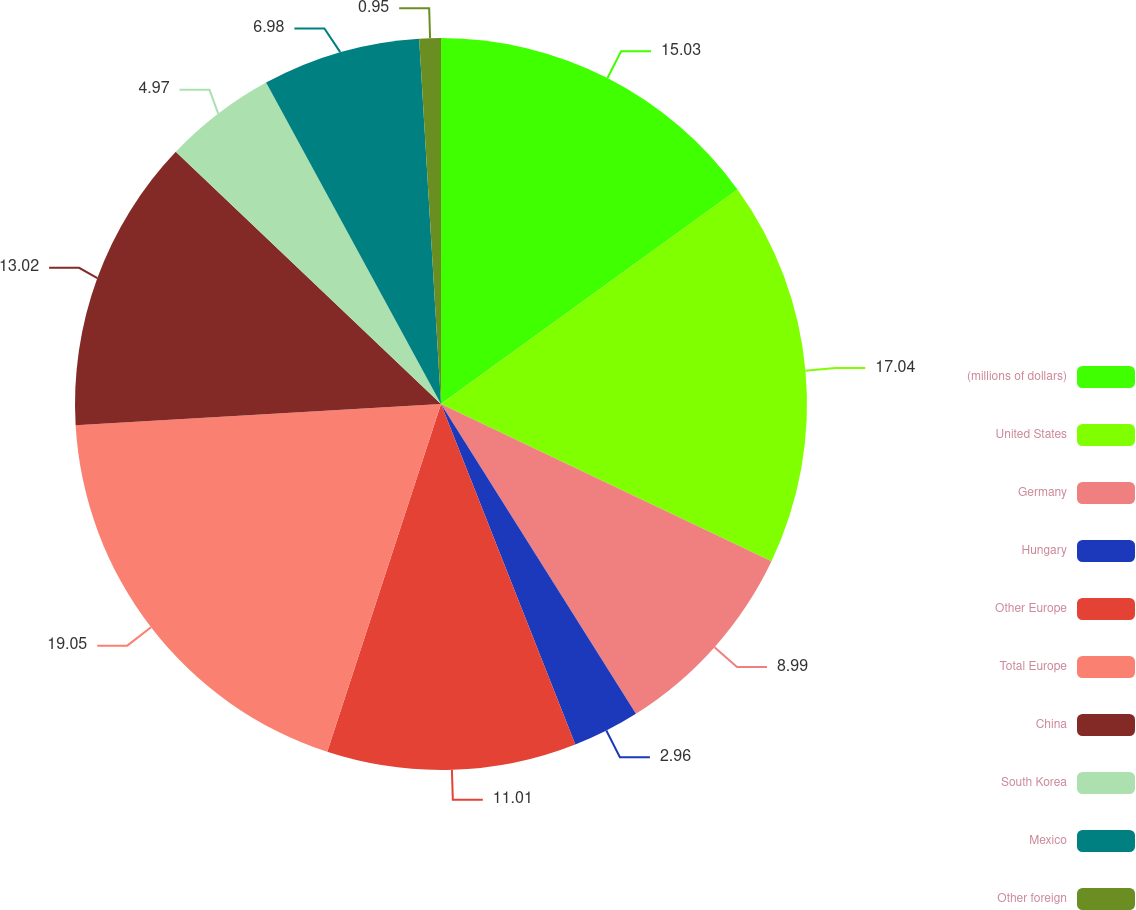Convert chart. <chart><loc_0><loc_0><loc_500><loc_500><pie_chart><fcel>(millions of dollars)<fcel>United States<fcel>Germany<fcel>Hungary<fcel>Other Europe<fcel>Total Europe<fcel>China<fcel>South Korea<fcel>Mexico<fcel>Other foreign<nl><fcel>15.03%<fcel>17.04%<fcel>8.99%<fcel>2.96%<fcel>11.01%<fcel>19.05%<fcel>13.02%<fcel>4.97%<fcel>6.98%<fcel>0.95%<nl></chart> 